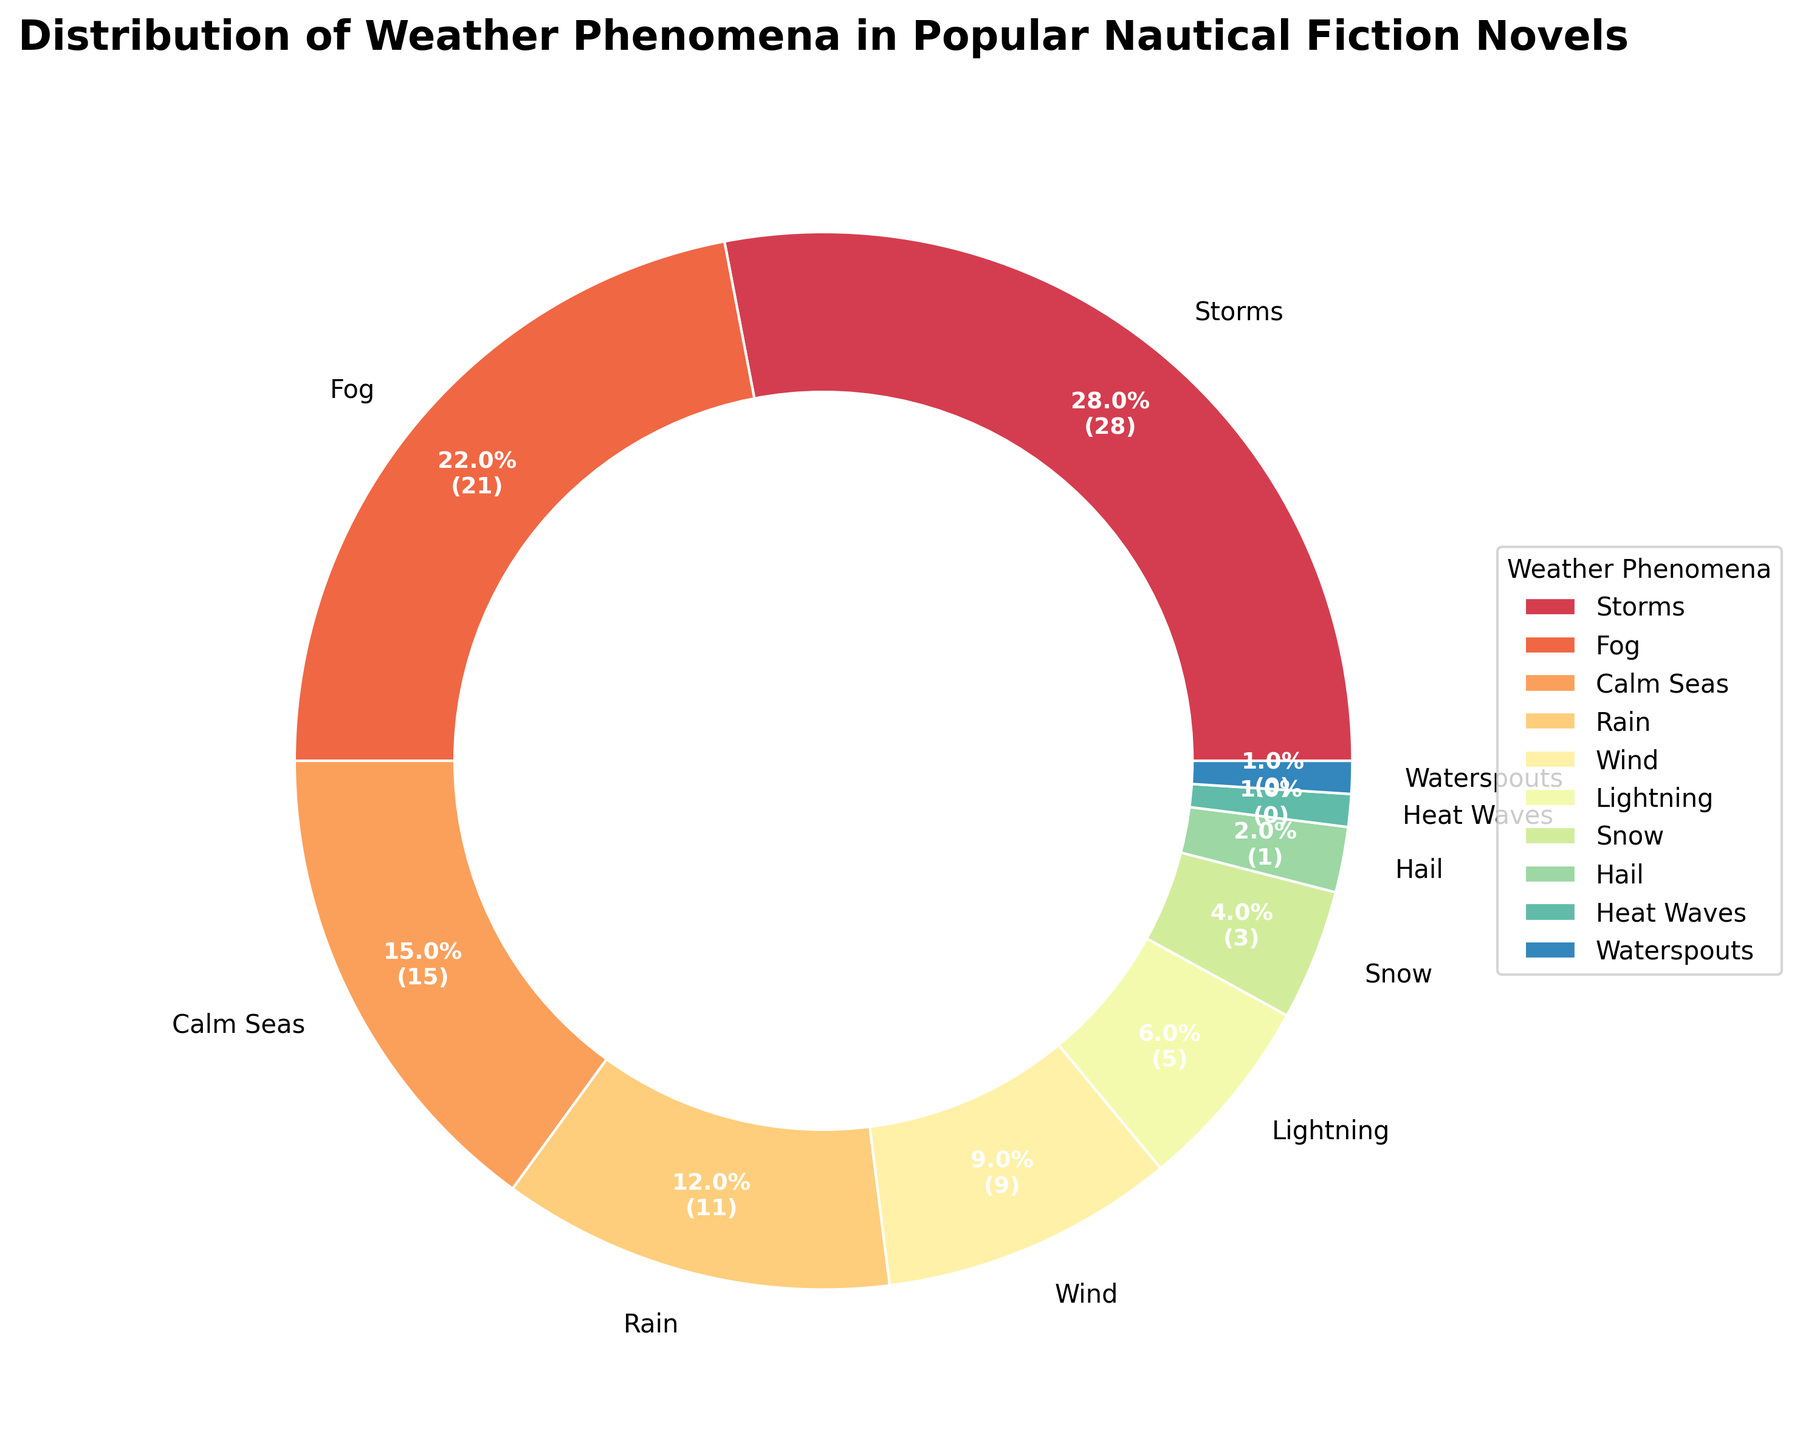Which weather phenomenon appears most frequently in nautical fiction novels? From the pie chart, the largest wedge represents storms, indicating it is the most frequent weather phenomenon.
Answer: Storms How many weather phenomena have a frequency percentage of less than 10%? By visually inspecting the pie chart, you can identify and count the slices representing percentages less than 10%. These include wind, lightning, snow, hail, waterspouts, and heat waves.
Answer: 6 Which phenomena combined contribute to over 50% of the weather phenomena described? You need to sum the percentages of the most frequent phenomena until the cumulative percentage exceeds 50%. Storms (28%), fog (22%), calm seas (15%), and rain (12%) together make up 77%.
Answer: Storms, Fog, Calm Seas, Rain What is the combined frequency of phenomena associated with precipitation (rain, snow, hail)? Adding the frequencies of rain (12), snow (4), and hail (2) gives 18.
Answer: 18 Are there more occurrences of storms or the combined occurrences of fog and calm seas? Comparing the frequency of storms (28) with the sum of fog (22) and calm seas (15), which totals 37, shows that combined, fog and calm seas have more occurrences.
Answer: Fog and Calm Seas Which weather phenomena appear less frequently than lightning? Observing the chart, snow (4), hail (2), waterspouts (1), and heat waves (1) all have smaller wedges compared to lightning (6).
Answer: Snow, Hail, Waterspouts, Heat Waves What is the difference in frequency between the most and the least common weather phenomena? Subtract the frequency of the least common phenomenon, heat waves (1), from the most common, storms (28), resulting in a difference of 27.
Answer: 27 Which phenomenon has approximately half the frequency of calm seas? Calm seas has a frequency of 15; half of that is around 7.5. Comparing this to the chart, wind has a frequency of 9, which is closest to half of calm seas.
Answer: Wind What percentage of the total does the phenomenon with the second-highest frequency represent? The second highest frequency is fog (22). To find its percentage, compute (22/100) * 100, resulting in 22%.
Answer: 22% Which has a higher frequency, wind or rain? By observing the chart, rain has a higher frequency (12) compared to wind (9).
Answer: Rain 